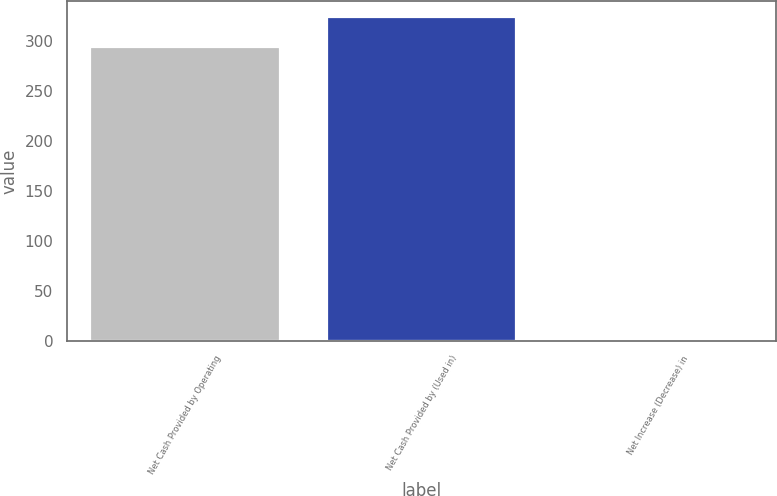Convert chart to OTSL. <chart><loc_0><loc_0><loc_500><loc_500><bar_chart><fcel>Net Cash Provided by Operating<fcel>Net Cash Provided by (Used in)<fcel>Net Increase (Decrease) in<nl><fcel>294<fcel>323.6<fcel>2<nl></chart> 